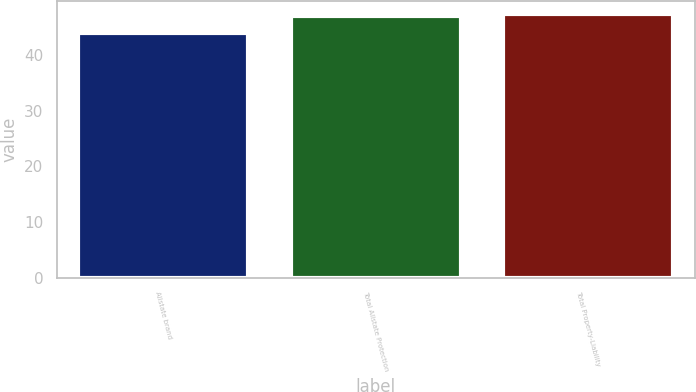<chart> <loc_0><loc_0><loc_500><loc_500><bar_chart><fcel>Allstate brand<fcel>Total Allstate Protection<fcel>Total Property-Liability<nl><fcel>44<fcel>47<fcel>47.3<nl></chart> 